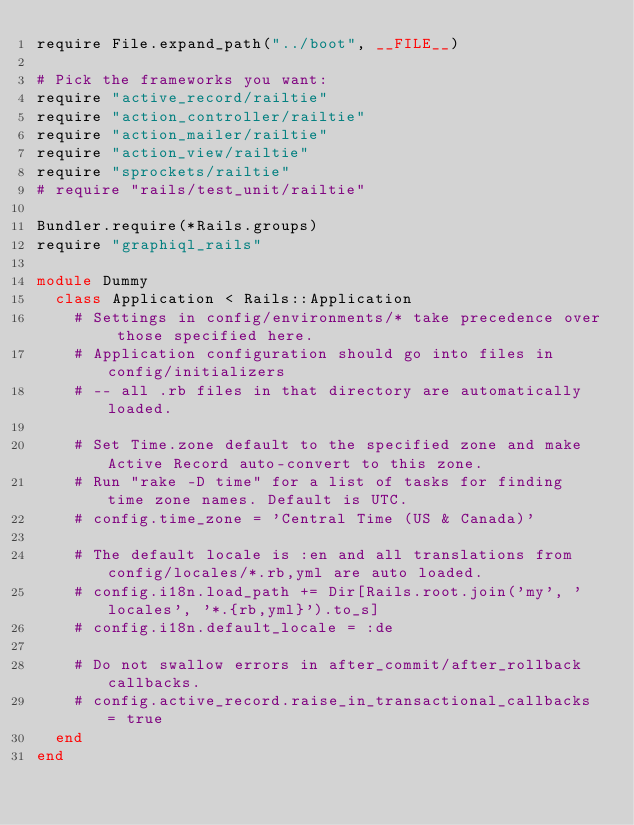<code> <loc_0><loc_0><loc_500><loc_500><_Ruby_>require File.expand_path("../boot", __FILE__)

# Pick the frameworks you want:
require "active_record/railtie"
require "action_controller/railtie"
require "action_mailer/railtie"
require "action_view/railtie"
require "sprockets/railtie"
# require "rails/test_unit/railtie"

Bundler.require(*Rails.groups)
require "graphiql_rails"

module Dummy
  class Application < Rails::Application
    # Settings in config/environments/* take precedence over those specified here.
    # Application configuration should go into files in config/initializers
    # -- all .rb files in that directory are automatically loaded.

    # Set Time.zone default to the specified zone and make Active Record auto-convert to this zone.
    # Run "rake -D time" for a list of tasks for finding time zone names. Default is UTC.
    # config.time_zone = 'Central Time (US & Canada)'

    # The default locale is :en and all translations from config/locales/*.rb,yml are auto loaded.
    # config.i18n.load_path += Dir[Rails.root.join('my', 'locales', '*.{rb,yml}').to_s]
    # config.i18n.default_locale = :de

    # Do not swallow errors in after_commit/after_rollback callbacks.
    # config.active_record.raise_in_transactional_callbacks = true
  end
end
</code> 